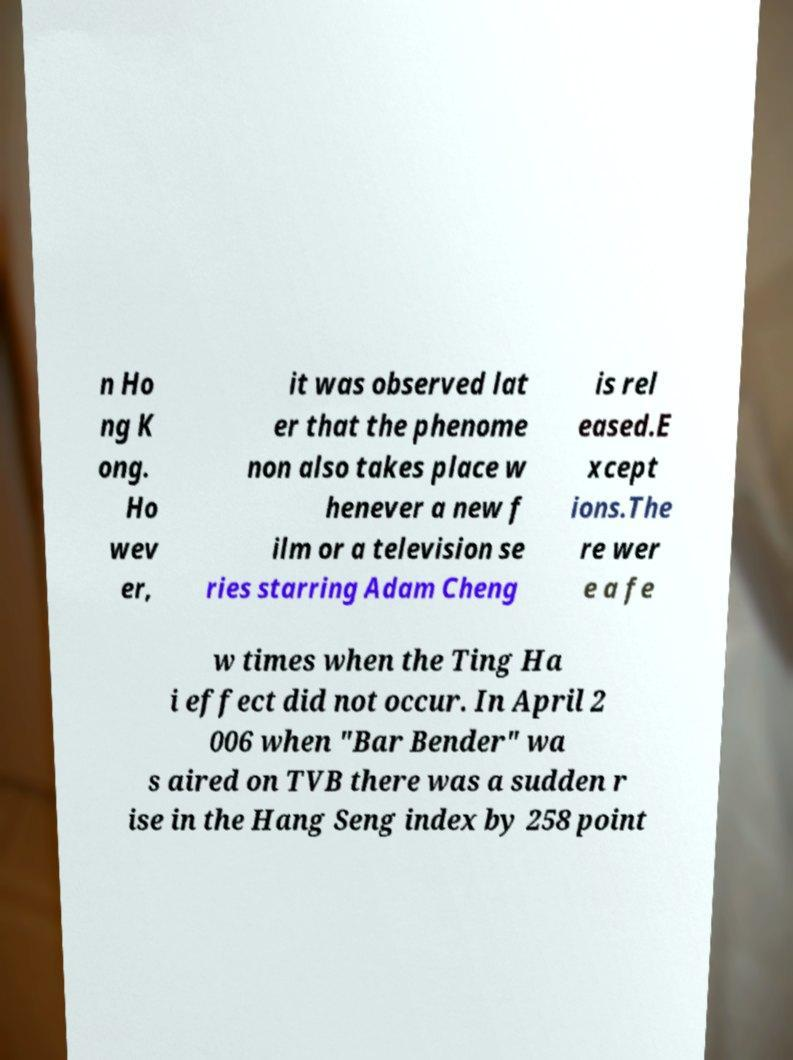Can you accurately transcribe the text from the provided image for me? n Ho ng K ong. Ho wev er, it was observed lat er that the phenome non also takes place w henever a new f ilm or a television se ries starring Adam Cheng is rel eased.E xcept ions.The re wer e a fe w times when the Ting Ha i effect did not occur. In April 2 006 when "Bar Bender" wa s aired on TVB there was a sudden r ise in the Hang Seng index by 258 point 